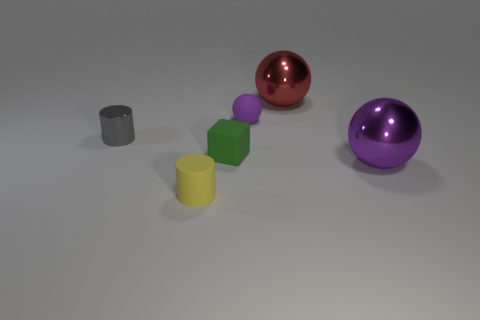Subtract all large red spheres. How many spheres are left? 2 Subtract all cylinders. How many objects are left? 4 Add 1 yellow rubber cylinders. How many objects exist? 7 Subtract all gray cylinders. How many cylinders are left? 1 Add 6 spheres. How many spheres are left? 9 Add 1 green rubber things. How many green rubber things exist? 2 Subtract 1 yellow cylinders. How many objects are left? 5 Subtract 2 cylinders. How many cylinders are left? 0 Subtract all gray cubes. Subtract all blue cylinders. How many cubes are left? 1 Subtract all gray cylinders. How many yellow spheres are left? 0 